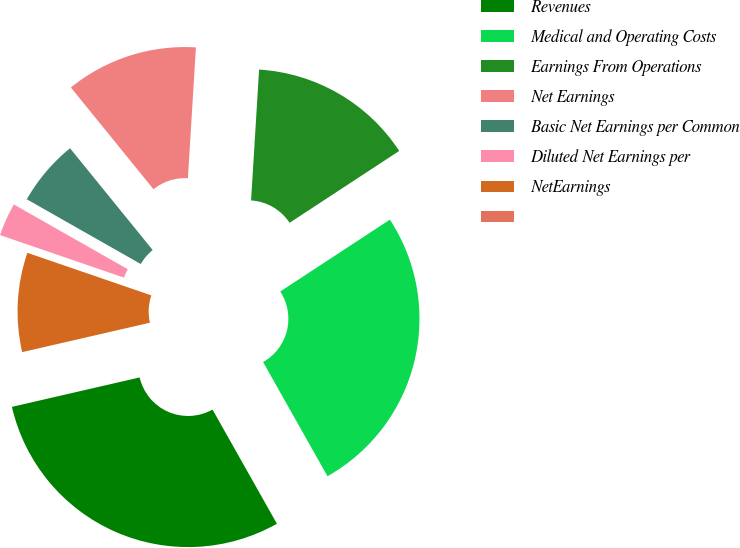Convert chart to OTSL. <chart><loc_0><loc_0><loc_500><loc_500><pie_chart><fcel>Revenues<fcel>Medical and Operating Costs<fcel>Earnings From Operations<fcel>Net Earnings<fcel>Basic Net Earnings per Common<fcel>Diluted Net Earnings per<fcel>NetEarnings<fcel>Unnamed: 7<nl><fcel>29.57%<fcel>26.06%<fcel>14.79%<fcel>11.83%<fcel>5.92%<fcel>2.96%<fcel>8.87%<fcel>0.0%<nl></chart> 